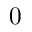Convert formula to latex. <formula><loc_0><loc_0><loc_500><loc_500>0</formula> 